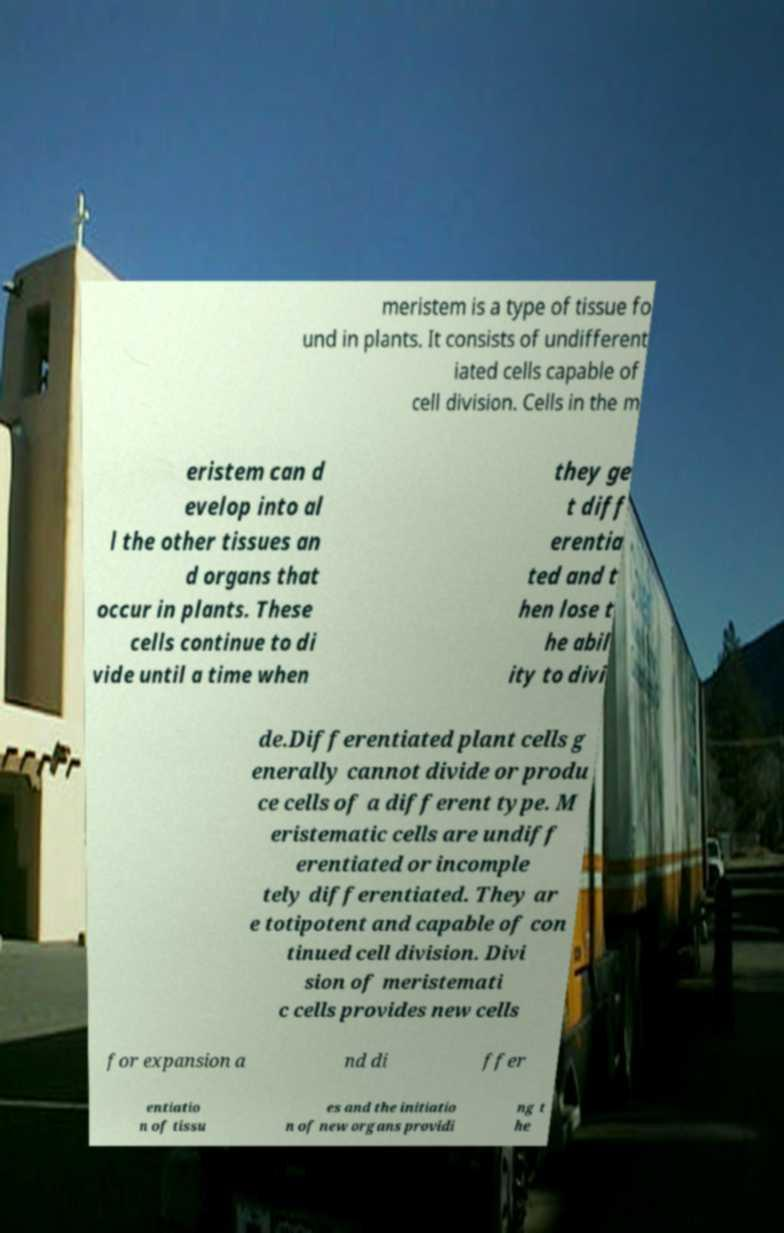What messages or text are displayed in this image? I need them in a readable, typed format. meristem is a type of tissue fo und in plants. It consists of undifferent iated cells capable of cell division. Cells in the m eristem can d evelop into al l the other tissues an d organs that occur in plants. These cells continue to di vide until a time when they ge t diff erentia ted and t hen lose t he abil ity to divi de.Differentiated plant cells g enerally cannot divide or produ ce cells of a different type. M eristematic cells are undiff erentiated or incomple tely differentiated. They ar e totipotent and capable of con tinued cell division. Divi sion of meristemati c cells provides new cells for expansion a nd di ffer entiatio n of tissu es and the initiatio n of new organs providi ng t he 